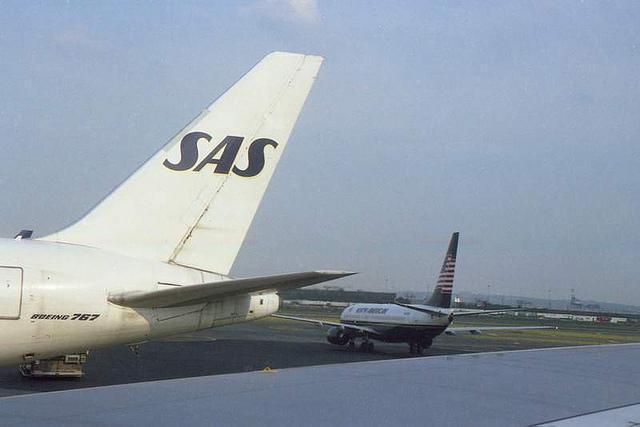How many planes are in the picture?
Give a very brief answer. 2. How many airplanes are visible?
Give a very brief answer. 2. 